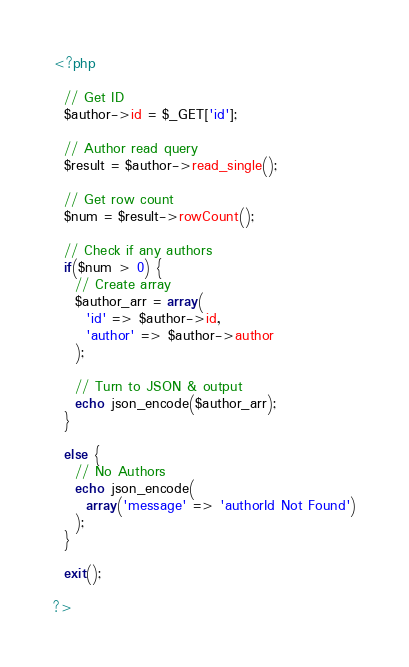Convert code to text. <code><loc_0><loc_0><loc_500><loc_500><_PHP_><?php

  // Get ID
  $author->id = $_GET['id'];

  // Author read query
  $result = $author->read_single();

  // Get row count
  $num = $result->rowCount();

  // Check if any authors
  if($num > 0) {
    // Create array
    $author_arr = array(
      'id' => $author->id,
      'author' => $author->author
    );

    // Turn to JSON & output
    echo json_encode($author_arr);
  } 
  
  else {
    // No Authors
    echo json_encode(
      array('message' => 'authorId Not Found')
    );
  }

  exit();

?></code> 